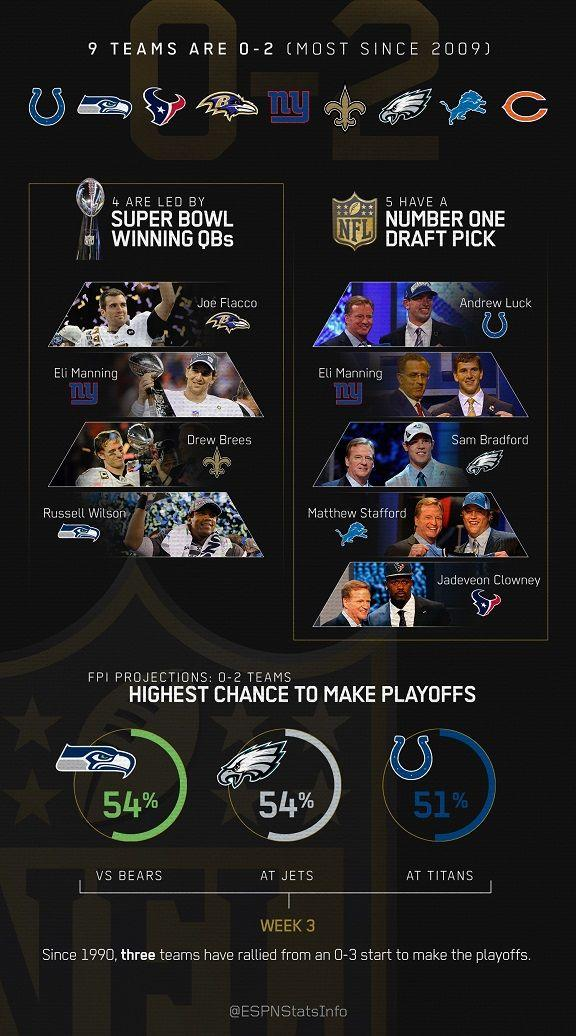Indicate a few pertinent items in this graphic. Eli Manning is a player who belongs to the category of Number One Draft Picks. 